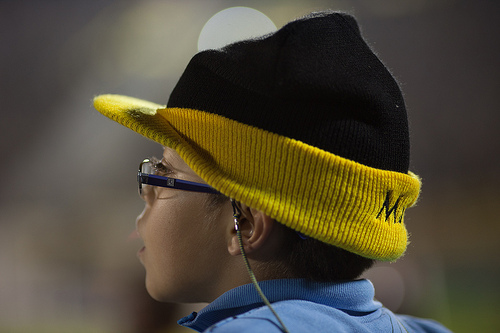<image>
Is the cap behind the glass? No. The cap is not behind the glass. From this viewpoint, the cap appears to be positioned elsewhere in the scene. 